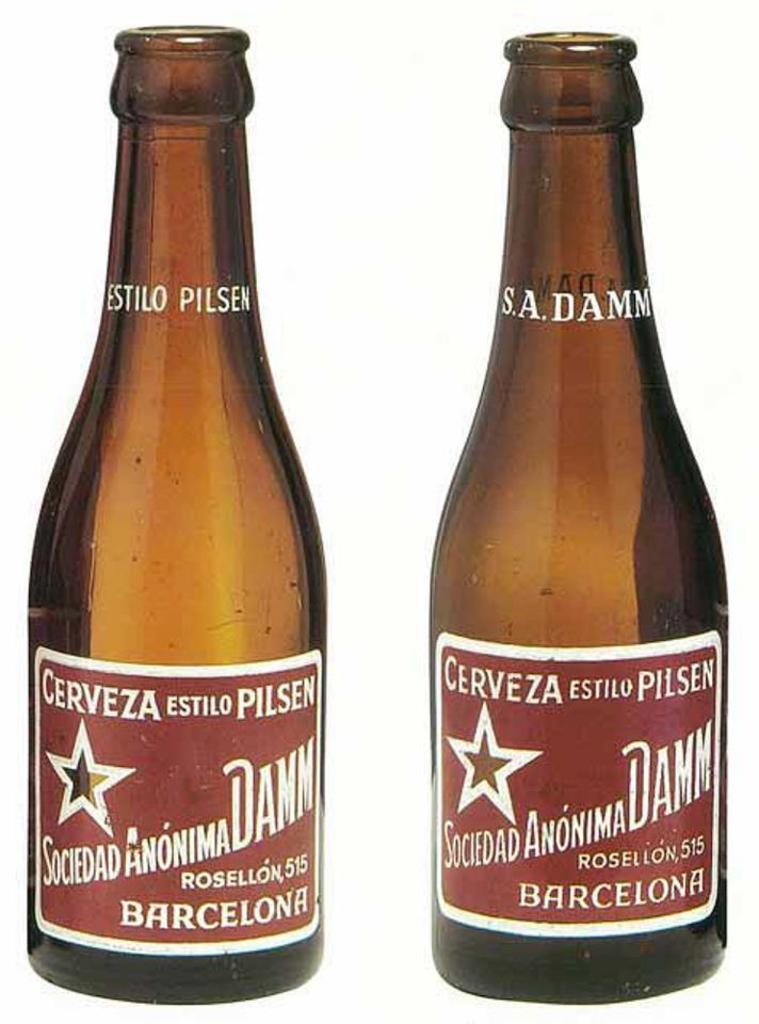<image>
Write a terse but informative summary of the picture. Two bottles of Cerveza estila Pilsen from Barcelona. 